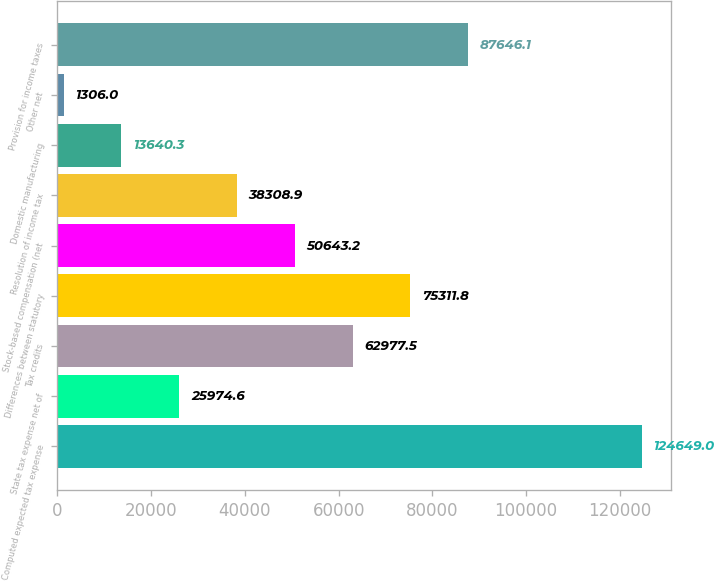Convert chart to OTSL. <chart><loc_0><loc_0><loc_500><loc_500><bar_chart><fcel>Computed expected tax expense<fcel>State tax expense net of<fcel>Tax credits<fcel>Differences between statutory<fcel>Stock-based compensation (net<fcel>Resolution of income tax<fcel>Domestic manufacturing<fcel>Other net<fcel>Provision for income taxes<nl><fcel>124649<fcel>25974.6<fcel>62977.5<fcel>75311.8<fcel>50643.2<fcel>38308.9<fcel>13640.3<fcel>1306<fcel>87646.1<nl></chart> 